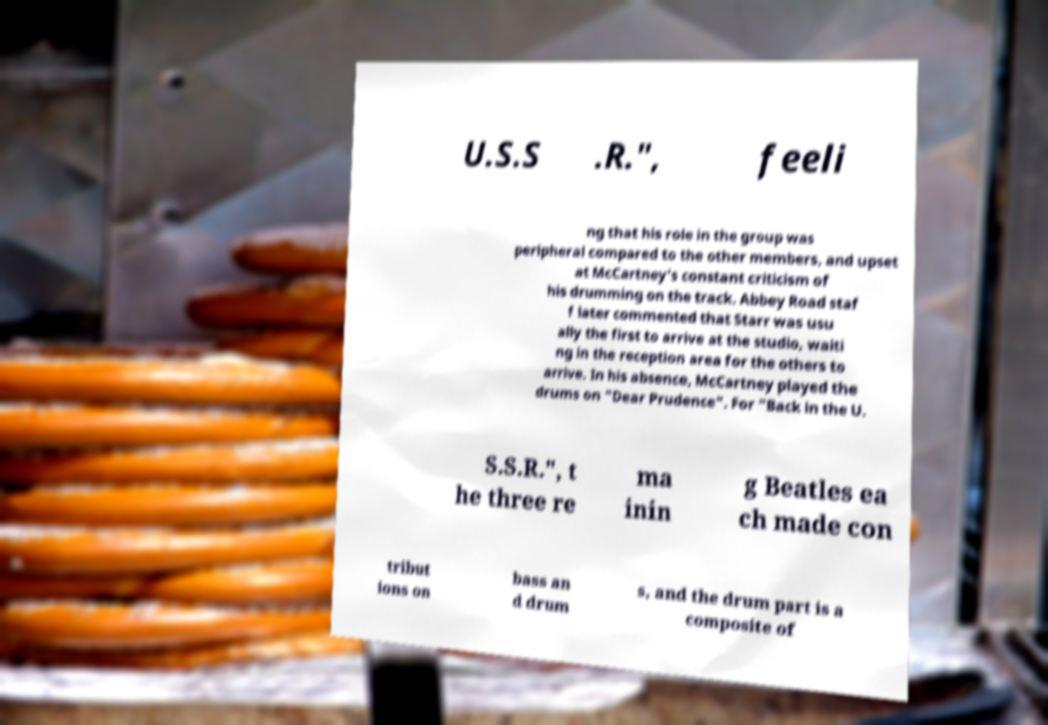Can you read and provide the text displayed in the image?This photo seems to have some interesting text. Can you extract and type it out for me? U.S.S .R.", feeli ng that his role in the group was peripheral compared to the other members, and upset at McCartney's constant criticism of his drumming on the track. Abbey Road staf f later commented that Starr was usu ally the first to arrive at the studio, waiti ng in the reception area for the others to arrive. In his absence, McCartney played the drums on "Dear Prudence". For "Back in the U. S.S.R.", t he three re ma inin g Beatles ea ch made con tribut ions on bass an d drum s, and the drum part is a composite of 